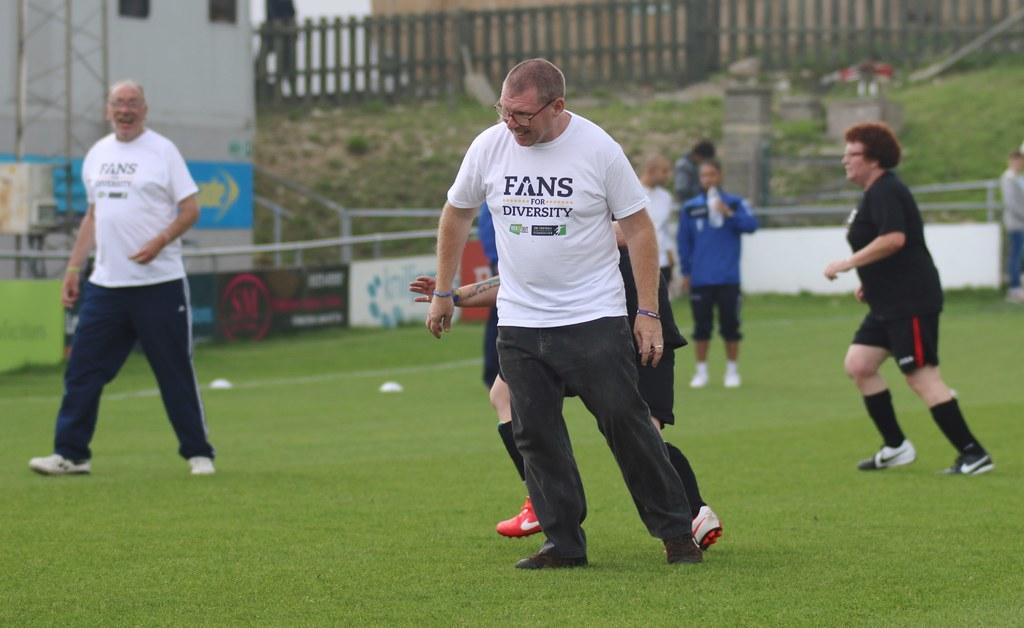What do their shirts say?
Offer a terse response. Fans for diversity. 